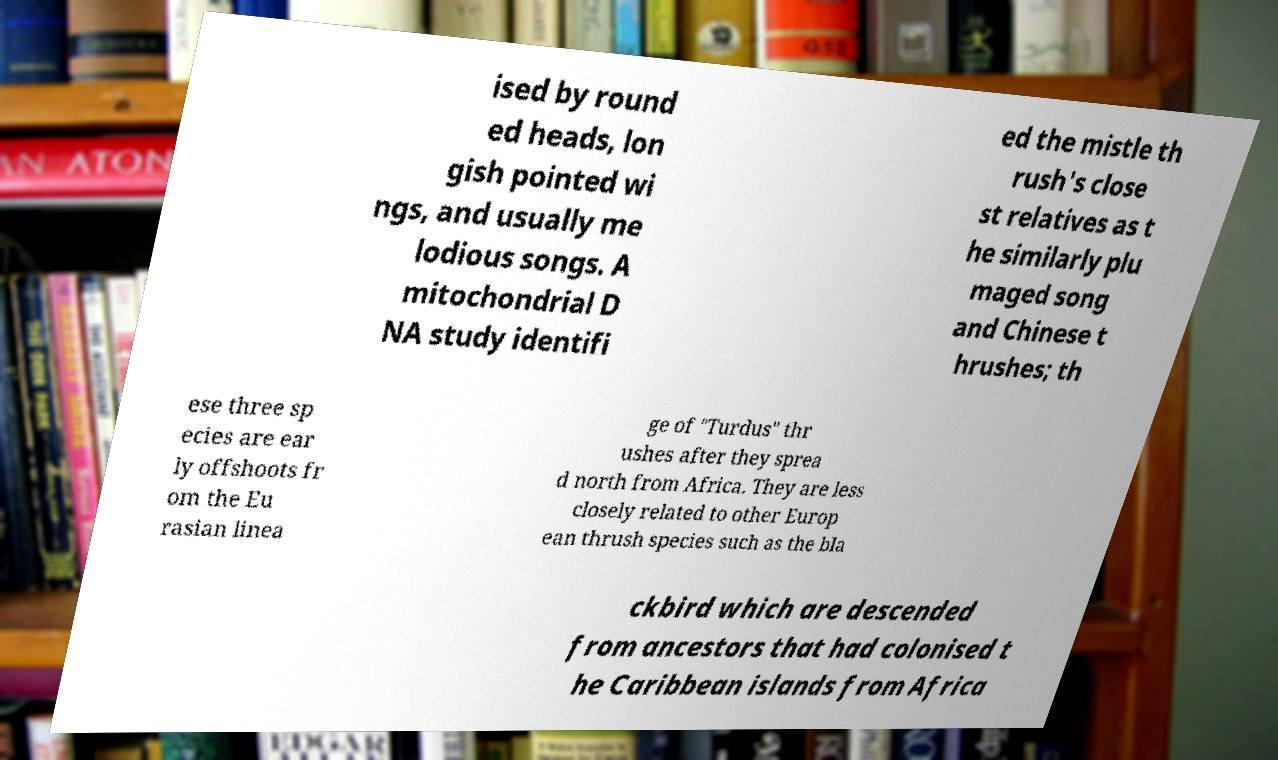Can you accurately transcribe the text from the provided image for me? ised by round ed heads, lon gish pointed wi ngs, and usually me lodious songs. A mitochondrial D NA study identifi ed the mistle th rush's close st relatives as t he similarly plu maged song and Chinese t hrushes; th ese three sp ecies are ear ly offshoots fr om the Eu rasian linea ge of "Turdus" thr ushes after they sprea d north from Africa. They are less closely related to other Europ ean thrush species such as the bla ckbird which are descended from ancestors that had colonised t he Caribbean islands from Africa 